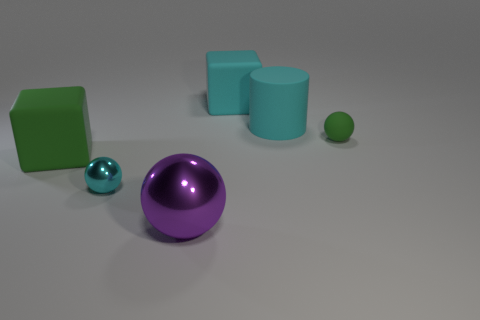Add 3 purple things. How many objects exist? 9 Subtract all cylinders. How many objects are left? 5 Add 6 shiny spheres. How many shiny spheres exist? 8 Subtract 0 gray cylinders. How many objects are left? 6 Subtract all big green rubber things. Subtract all big matte cylinders. How many objects are left? 4 Add 3 green matte balls. How many green matte balls are left? 4 